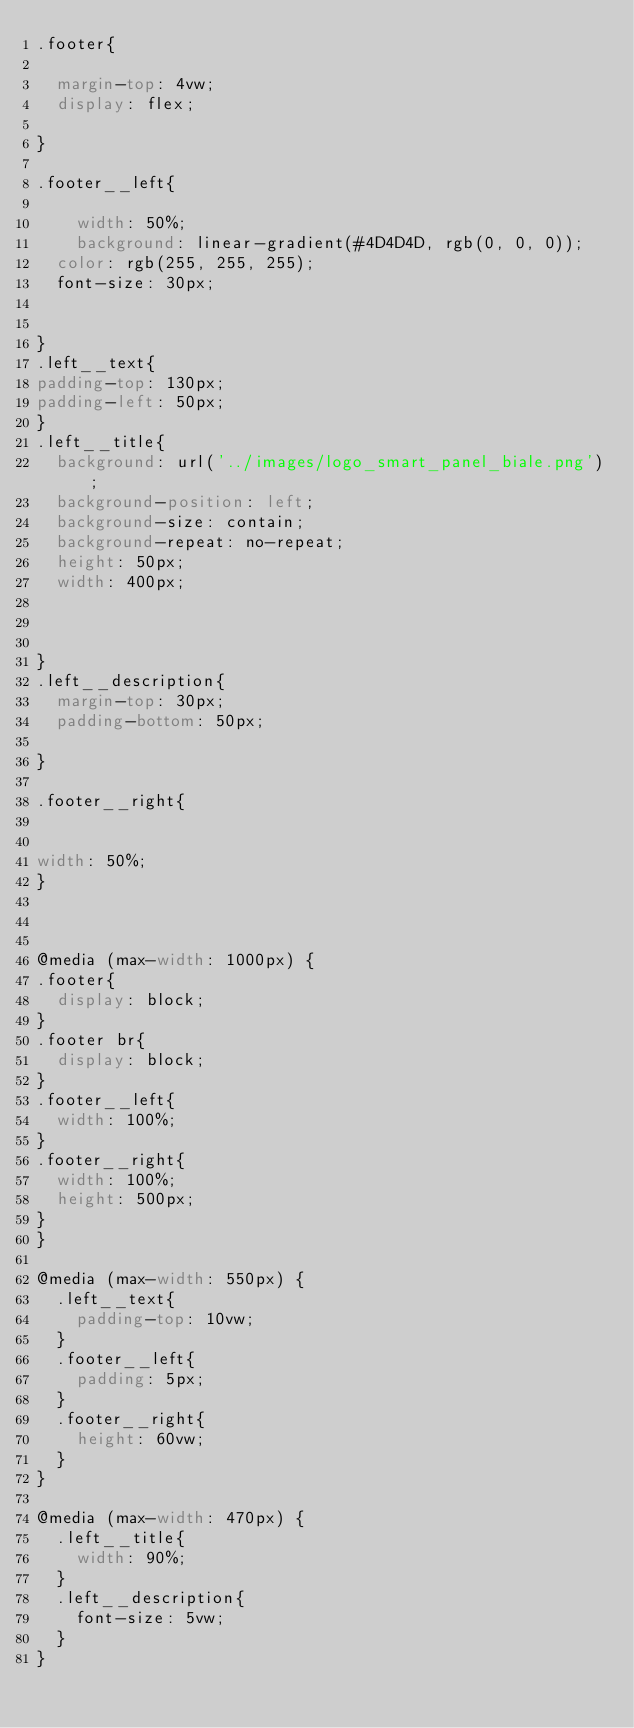Convert code to text. <code><loc_0><loc_0><loc_500><loc_500><_CSS_>.footer{
  
  margin-top: 4vw;
  display: flex;
  
}

.footer__left{
   
    width: 50%;
    background: linear-gradient(#4D4D4D, rgb(0, 0, 0));
  color: rgb(255, 255, 255);
  font-size: 30px;
  
  
}
.left__text{
padding-top: 130px;
padding-left: 50px;
}
.left__title{
  background: url('../images/logo_smart_panel_biale.png');
  background-position: left;
  background-size: contain;
  background-repeat: no-repeat;
  height: 50px;
  width: 400px;
 
 
  
}
.left__description{
  margin-top: 30px;
  padding-bottom: 50px;
  
}

.footer__right{


width: 50%;
}



@media (max-width: 1000px) {
.footer{
  display: block;
}
.footer br{
  display: block;
}
.footer__left{
  width: 100%;
}
.footer__right{
  width: 100%;
  height: 500px;
}
}

@media (max-width: 550px) {
  .left__text{
    padding-top: 10vw; 
  }
  .footer__left{
    padding: 5px;
  }
  .footer__right{
    height: 60vw;
  }
}

@media (max-width: 470px) {
  .left__title{
    width: 90%;
  }
  .left__description{
    font-size: 5vw;
  }
}</code> 